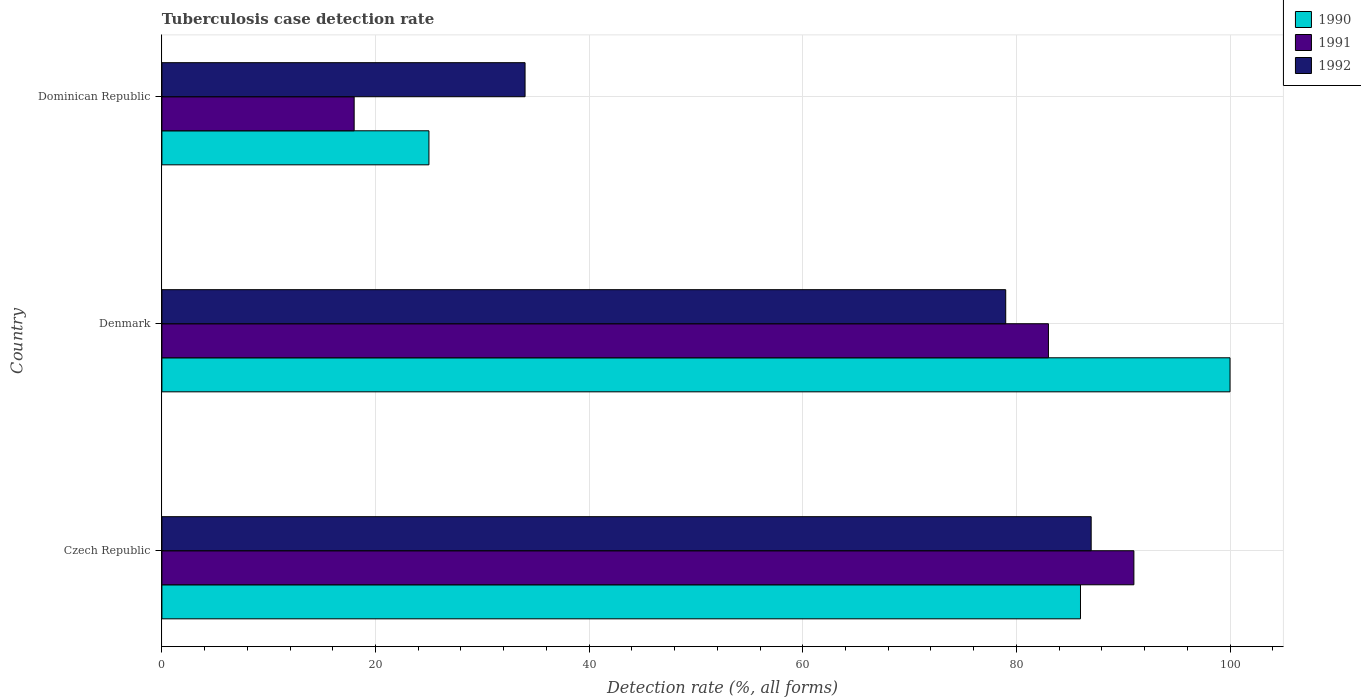How many different coloured bars are there?
Make the answer very short. 3. Are the number of bars per tick equal to the number of legend labels?
Your response must be concise. Yes. How many bars are there on the 3rd tick from the bottom?
Give a very brief answer. 3. What is the label of the 1st group of bars from the top?
Ensure brevity in your answer.  Dominican Republic. What is the tuberculosis case detection rate in in 1990 in Denmark?
Keep it short and to the point. 100. Across all countries, what is the maximum tuberculosis case detection rate in in 1992?
Your answer should be compact. 87. Across all countries, what is the minimum tuberculosis case detection rate in in 1992?
Provide a short and direct response. 34. In which country was the tuberculosis case detection rate in in 1991 maximum?
Make the answer very short. Czech Republic. In which country was the tuberculosis case detection rate in in 1990 minimum?
Ensure brevity in your answer.  Dominican Republic. What is the total tuberculosis case detection rate in in 1990 in the graph?
Your answer should be compact. 211. What is the difference between the tuberculosis case detection rate in in 1990 in Denmark and the tuberculosis case detection rate in in 1992 in Czech Republic?
Make the answer very short. 13. What is the average tuberculosis case detection rate in in 1991 per country?
Keep it short and to the point. 64. What is the difference between the tuberculosis case detection rate in in 1990 and tuberculosis case detection rate in in 1991 in Dominican Republic?
Provide a succinct answer. 7. In how many countries, is the tuberculosis case detection rate in in 1991 greater than 12 %?
Offer a terse response. 3. What is the ratio of the tuberculosis case detection rate in in 1992 in Denmark to that in Dominican Republic?
Offer a very short reply. 2.32. Is the tuberculosis case detection rate in in 1991 in Czech Republic less than that in Denmark?
Your answer should be compact. No. Is the difference between the tuberculosis case detection rate in in 1990 in Denmark and Dominican Republic greater than the difference between the tuberculosis case detection rate in in 1991 in Denmark and Dominican Republic?
Ensure brevity in your answer.  Yes. What is the difference between the highest and the lowest tuberculosis case detection rate in in 1990?
Offer a terse response. 75. In how many countries, is the tuberculosis case detection rate in in 1990 greater than the average tuberculosis case detection rate in in 1990 taken over all countries?
Your answer should be compact. 2. What does the 1st bar from the top in Dominican Republic represents?
Offer a terse response. 1992. What does the 3rd bar from the bottom in Dominican Republic represents?
Provide a short and direct response. 1992. Is it the case that in every country, the sum of the tuberculosis case detection rate in in 1991 and tuberculosis case detection rate in in 1990 is greater than the tuberculosis case detection rate in in 1992?
Your answer should be compact. Yes. Are all the bars in the graph horizontal?
Offer a very short reply. Yes. How many legend labels are there?
Provide a succinct answer. 3. What is the title of the graph?
Keep it short and to the point. Tuberculosis case detection rate. Does "1964" appear as one of the legend labels in the graph?
Give a very brief answer. No. What is the label or title of the X-axis?
Keep it short and to the point. Detection rate (%, all forms). What is the Detection rate (%, all forms) of 1990 in Czech Republic?
Offer a very short reply. 86. What is the Detection rate (%, all forms) in 1991 in Czech Republic?
Offer a very short reply. 91. What is the Detection rate (%, all forms) in 1992 in Czech Republic?
Give a very brief answer. 87. What is the Detection rate (%, all forms) in 1992 in Denmark?
Your answer should be compact. 79. What is the Detection rate (%, all forms) in 1991 in Dominican Republic?
Offer a terse response. 18. What is the Detection rate (%, all forms) of 1992 in Dominican Republic?
Give a very brief answer. 34. Across all countries, what is the maximum Detection rate (%, all forms) of 1990?
Offer a very short reply. 100. Across all countries, what is the maximum Detection rate (%, all forms) of 1991?
Your response must be concise. 91. Across all countries, what is the minimum Detection rate (%, all forms) of 1991?
Make the answer very short. 18. What is the total Detection rate (%, all forms) of 1990 in the graph?
Offer a very short reply. 211. What is the total Detection rate (%, all forms) of 1991 in the graph?
Offer a terse response. 192. What is the difference between the Detection rate (%, all forms) of 1990 in Czech Republic and that in Denmark?
Give a very brief answer. -14. What is the difference between the Detection rate (%, all forms) in 1991 in Czech Republic and that in Denmark?
Make the answer very short. 8. What is the difference between the Detection rate (%, all forms) in 1992 in Czech Republic and that in Denmark?
Provide a succinct answer. 8. What is the difference between the Detection rate (%, all forms) of 1992 in Czech Republic and that in Dominican Republic?
Your answer should be very brief. 53. What is the difference between the Detection rate (%, all forms) of 1990 in Denmark and that in Dominican Republic?
Your answer should be very brief. 75. What is the difference between the Detection rate (%, all forms) in 1991 in Denmark and that in Dominican Republic?
Your response must be concise. 65. What is the difference between the Detection rate (%, all forms) of 1992 in Denmark and that in Dominican Republic?
Ensure brevity in your answer.  45. What is the difference between the Detection rate (%, all forms) in 1990 in Czech Republic and the Detection rate (%, all forms) in 1991 in Denmark?
Make the answer very short. 3. What is the difference between the Detection rate (%, all forms) in 1990 in Czech Republic and the Detection rate (%, all forms) in 1992 in Denmark?
Your response must be concise. 7. What is the difference between the Detection rate (%, all forms) in 1991 in Czech Republic and the Detection rate (%, all forms) in 1992 in Denmark?
Your response must be concise. 12. What is the difference between the Detection rate (%, all forms) in 1990 in Denmark and the Detection rate (%, all forms) in 1991 in Dominican Republic?
Give a very brief answer. 82. What is the difference between the Detection rate (%, all forms) in 1990 in Denmark and the Detection rate (%, all forms) in 1992 in Dominican Republic?
Ensure brevity in your answer.  66. What is the average Detection rate (%, all forms) of 1990 per country?
Make the answer very short. 70.33. What is the average Detection rate (%, all forms) in 1991 per country?
Make the answer very short. 64. What is the average Detection rate (%, all forms) of 1992 per country?
Your response must be concise. 66.67. What is the difference between the Detection rate (%, all forms) of 1990 and Detection rate (%, all forms) of 1992 in Denmark?
Keep it short and to the point. 21. What is the difference between the Detection rate (%, all forms) of 1991 and Detection rate (%, all forms) of 1992 in Denmark?
Offer a terse response. 4. What is the difference between the Detection rate (%, all forms) in 1990 and Detection rate (%, all forms) in 1991 in Dominican Republic?
Ensure brevity in your answer.  7. What is the difference between the Detection rate (%, all forms) of 1991 and Detection rate (%, all forms) of 1992 in Dominican Republic?
Your answer should be compact. -16. What is the ratio of the Detection rate (%, all forms) of 1990 in Czech Republic to that in Denmark?
Give a very brief answer. 0.86. What is the ratio of the Detection rate (%, all forms) in 1991 in Czech Republic to that in Denmark?
Give a very brief answer. 1.1. What is the ratio of the Detection rate (%, all forms) in 1992 in Czech Republic to that in Denmark?
Keep it short and to the point. 1.1. What is the ratio of the Detection rate (%, all forms) of 1990 in Czech Republic to that in Dominican Republic?
Provide a succinct answer. 3.44. What is the ratio of the Detection rate (%, all forms) of 1991 in Czech Republic to that in Dominican Republic?
Your response must be concise. 5.06. What is the ratio of the Detection rate (%, all forms) in 1992 in Czech Republic to that in Dominican Republic?
Your answer should be compact. 2.56. What is the ratio of the Detection rate (%, all forms) of 1990 in Denmark to that in Dominican Republic?
Provide a succinct answer. 4. What is the ratio of the Detection rate (%, all forms) of 1991 in Denmark to that in Dominican Republic?
Keep it short and to the point. 4.61. What is the ratio of the Detection rate (%, all forms) of 1992 in Denmark to that in Dominican Republic?
Provide a succinct answer. 2.32. What is the difference between the highest and the second highest Detection rate (%, all forms) in 1991?
Offer a very short reply. 8. What is the difference between the highest and the lowest Detection rate (%, all forms) of 1990?
Provide a succinct answer. 75. What is the difference between the highest and the lowest Detection rate (%, all forms) of 1992?
Offer a very short reply. 53. 